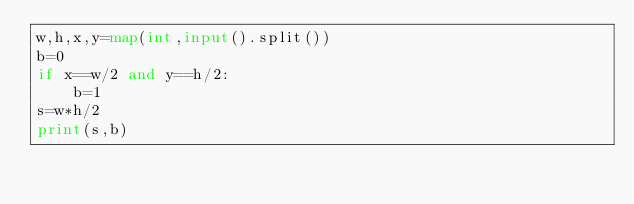<code> <loc_0><loc_0><loc_500><loc_500><_Python_>w,h,x,y=map(int,input().split())
b=0
if x==w/2 and y==h/2:
    b=1
s=w*h/2
print(s,b)</code> 